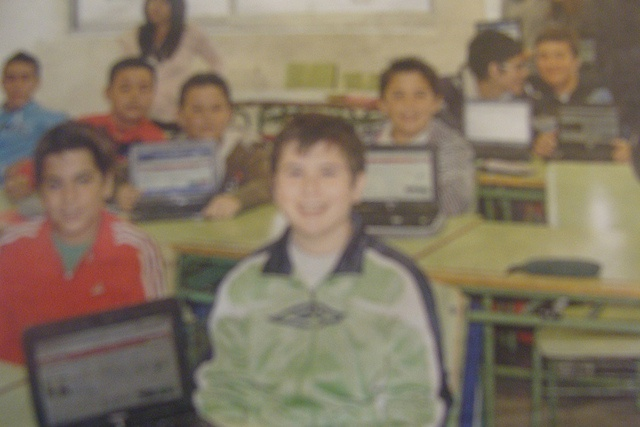Describe the objects in this image and their specific colors. I can see people in darkgray and gray tones, people in darkgray, brown, and gray tones, laptop in darkgray, gray, and black tones, people in darkgray and gray tones, and people in darkgray and gray tones in this image. 